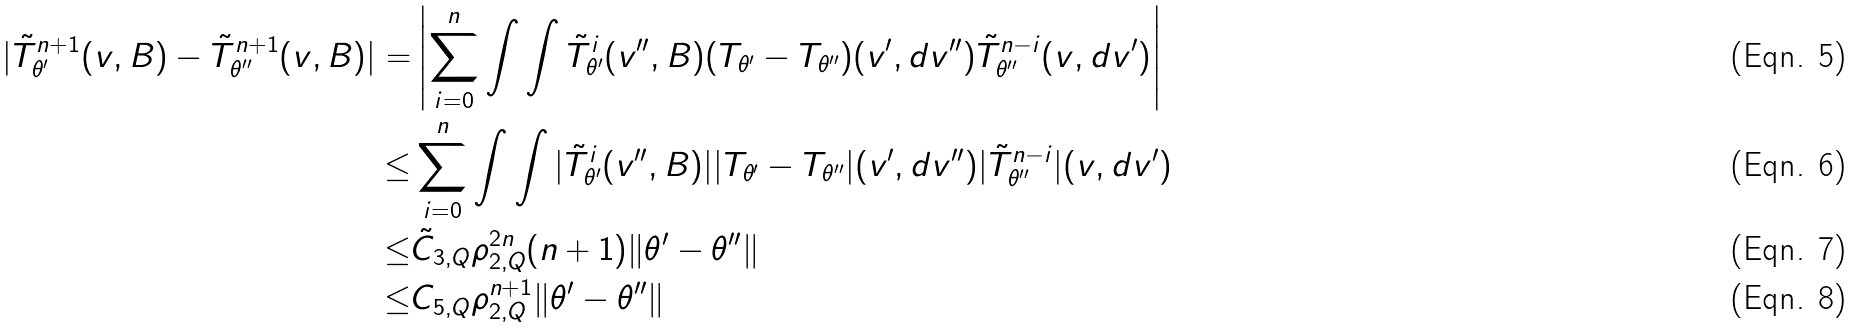<formula> <loc_0><loc_0><loc_500><loc_500>| \tilde { T } _ { \theta ^ { \prime } } ^ { n + 1 } ( v , B ) - \tilde { T } _ { \theta ^ { \prime \prime } } ^ { n + 1 } ( v , B ) | = & \left | \sum _ { i = 0 } ^ { n } \int \int \tilde { T } _ { \theta ^ { \prime } } ^ { i } ( v ^ { \prime \prime } , B ) ( T _ { \theta ^ { \prime } } - T _ { \theta ^ { \prime \prime } } ) ( v ^ { \prime } , d v ^ { \prime \prime } ) \tilde { T } _ { \theta ^ { \prime \prime } } ^ { n - i } ( v , d v ^ { \prime } ) \right | \\ \leq & \sum _ { i = 0 } ^ { n } \int \int | \tilde { T } _ { \theta ^ { \prime } } ^ { i } ( v ^ { \prime \prime } , B ) | | T _ { \theta ^ { \prime } } - T _ { \theta ^ { \prime \prime } } | ( v ^ { \prime } , d v ^ { \prime \prime } ) | \tilde { T } _ { \theta ^ { \prime \prime } } ^ { n - i } | ( v , d v ^ { \prime } ) \\ \leq & \tilde { C } _ { 3 , Q } \rho _ { 2 , Q } ^ { 2 n } ( n + 1 ) \| \theta ^ { \prime } - \theta ^ { \prime \prime } \| \\ \leq & C _ { 5 , Q } \rho _ { 2 , Q } ^ { n + 1 } \| \theta ^ { \prime } - \theta ^ { \prime \prime } \|</formula> 